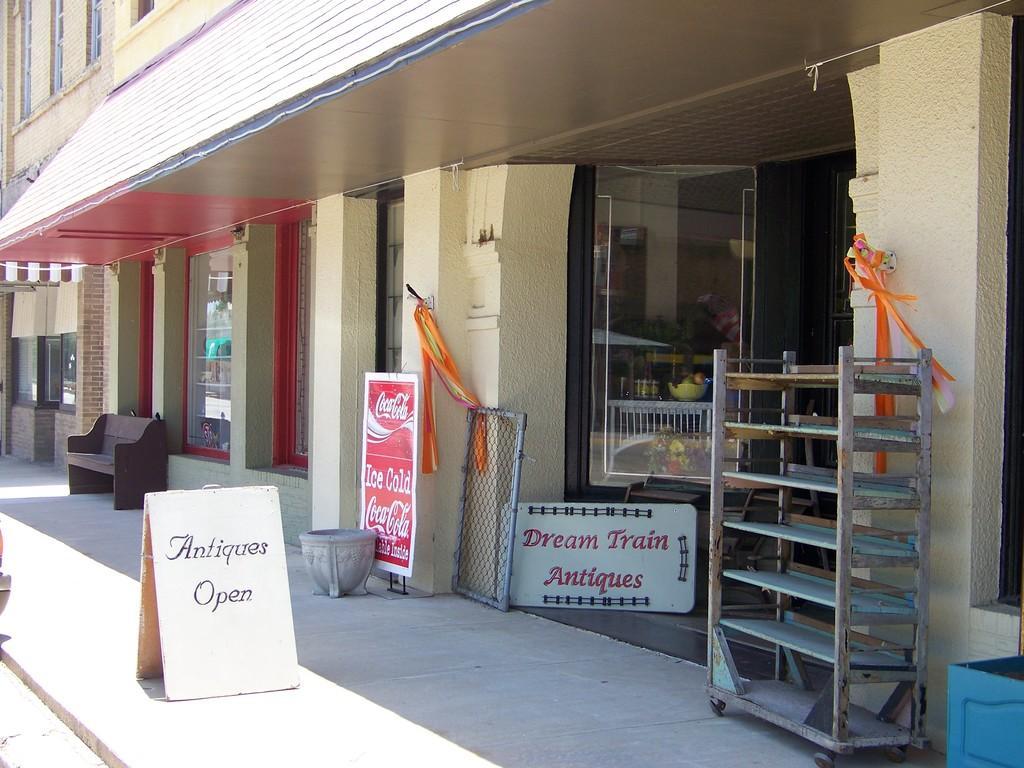Please provide a concise description of this image. In this image I can see the buildings. I can see the boards and the bench in-front of the building. I can see the rack and some objects can be seen. 